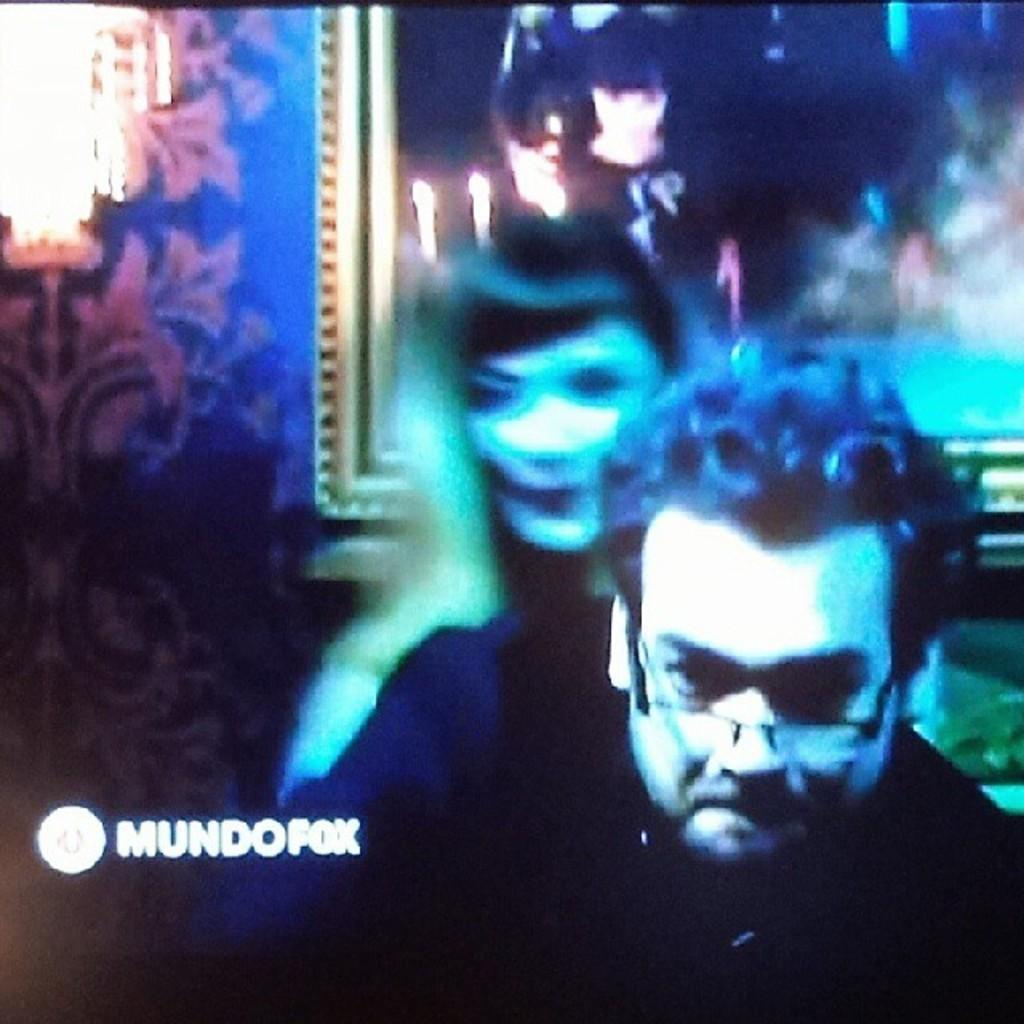How many people are present in the image? There is a man and a woman in the image. What can be seen on the wall in the image? There is a photo frame on the wall. What type of lighting fixture is visible in the image? There is a chandelier in the image. What is the background element in the image? There is a wall in the image. What type of corn can be seen growing on the wall in the image? There is no corn present in the image; it features a man, a woman, a wall with a photo frame, and a chandelier. Is there a crook visible in the image? There is no crook present in the image. 